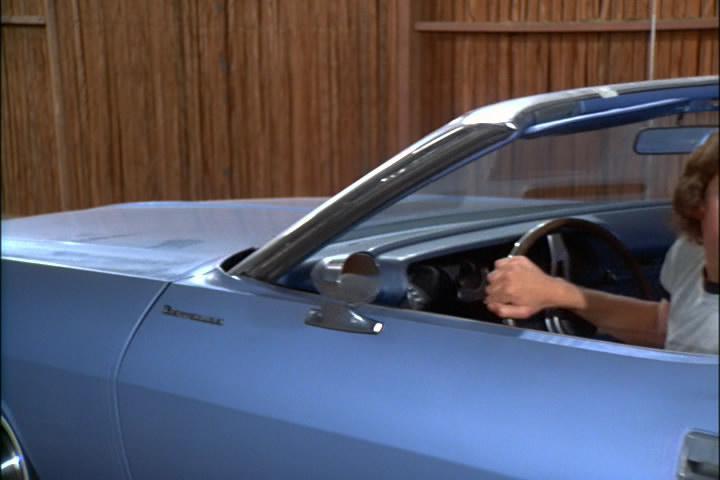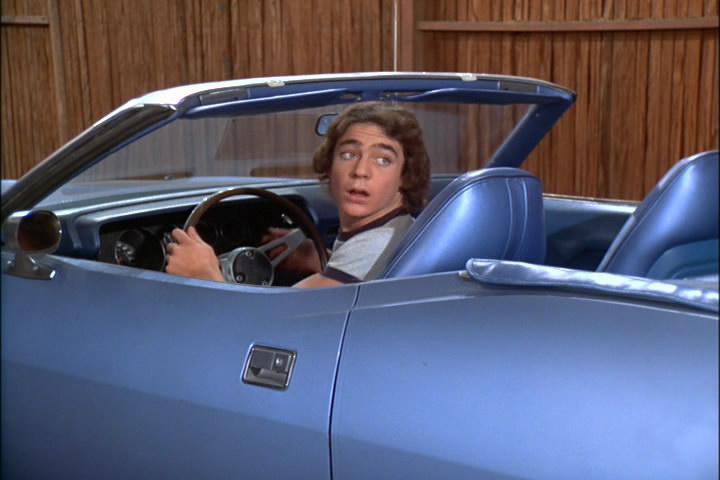The first image is the image on the left, the second image is the image on the right. Assess this claim about the two images: "Both images have a brown wooden fence in the background.". Correct or not? Answer yes or no. Yes. The first image is the image on the left, the second image is the image on the right. Evaluate the accuracy of this statement regarding the images: "Two people are sitting in a car in at least one of the images.". Is it true? Answer yes or no. No. 